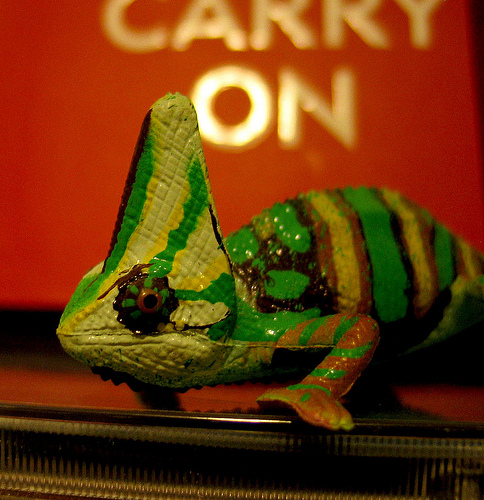<image>
Can you confirm if the yellow stripes is on the pink wall? No. The yellow stripes is not positioned on the pink wall. They may be near each other, but the yellow stripes is not supported by or resting on top of the pink wall. 